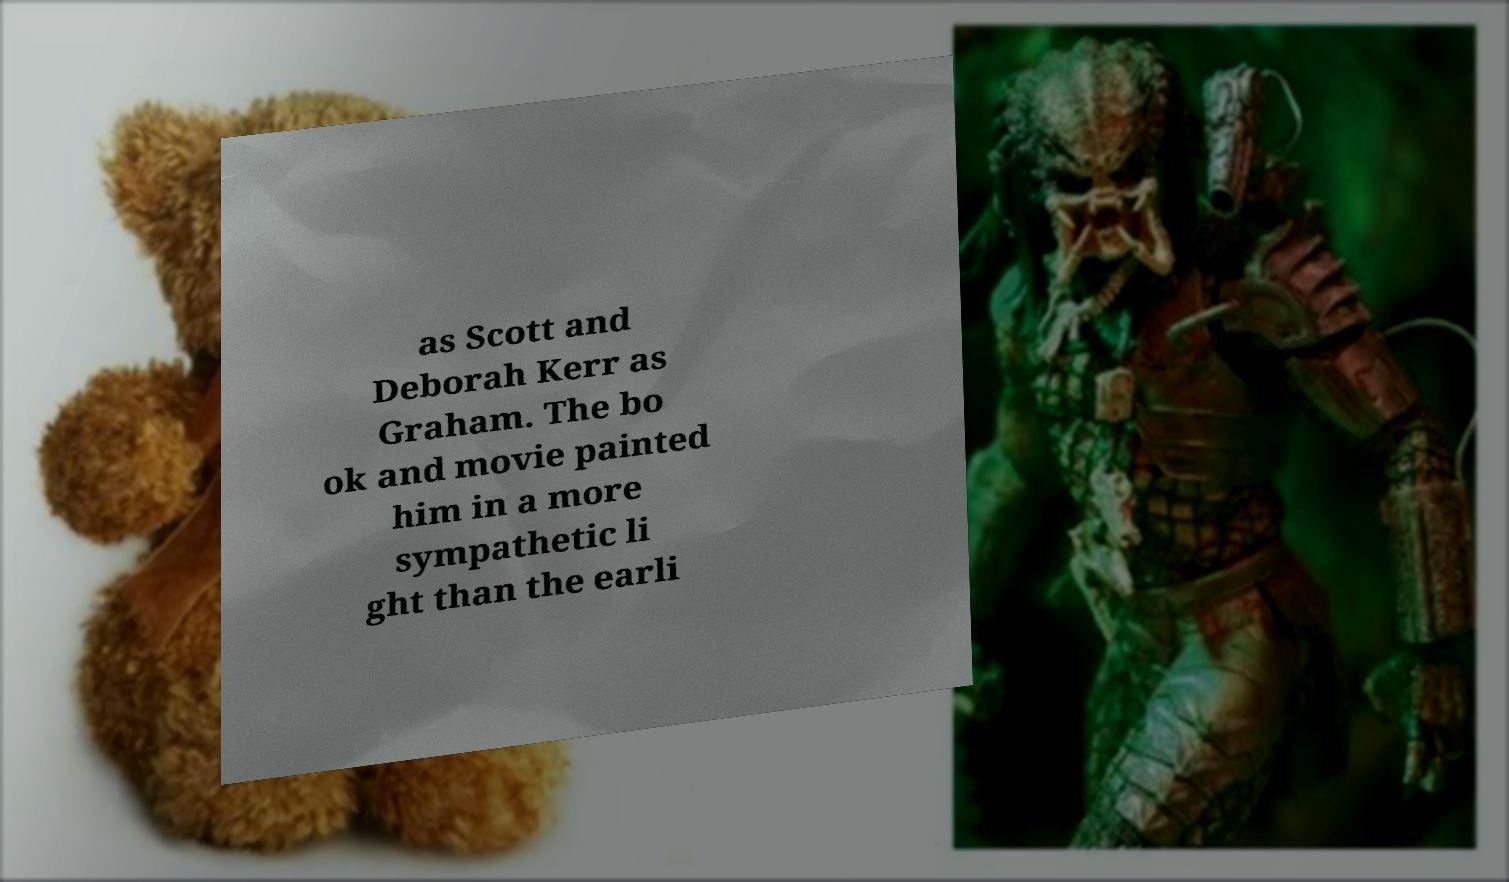I need the written content from this picture converted into text. Can you do that? as Scott and Deborah Kerr as Graham. The bo ok and movie painted him in a more sympathetic li ght than the earli 